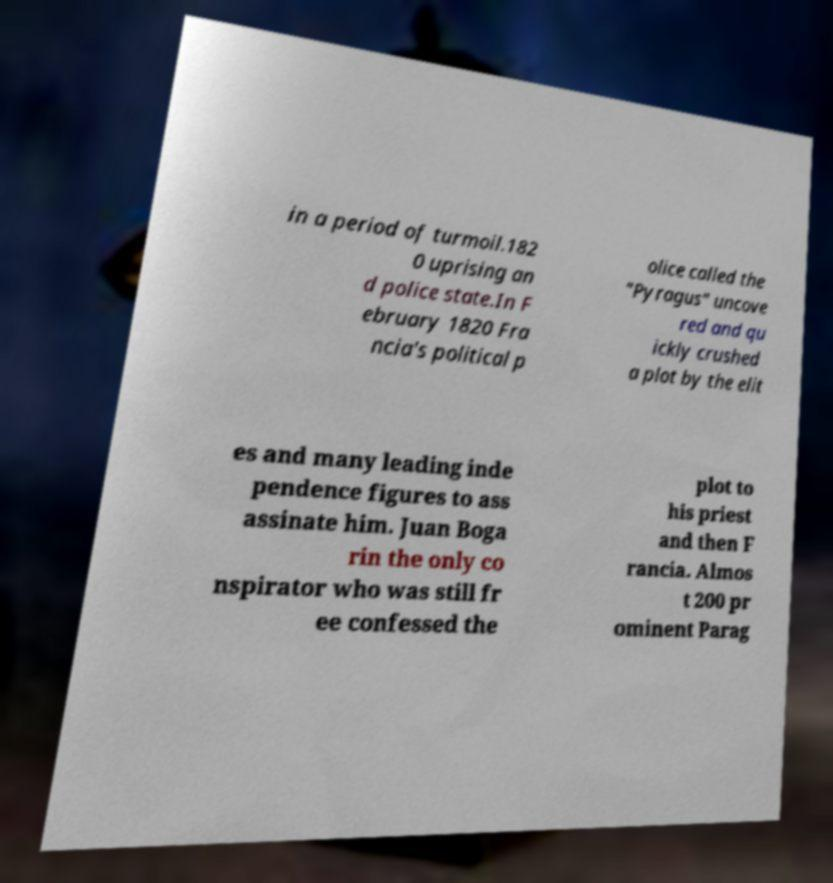Could you assist in decoding the text presented in this image and type it out clearly? in a period of turmoil.182 0 uprising an d police state.In F ebruary 1820 Fra ncia's political p olice called the "Pyragus" uncove red and qu ickly crushed a plot by the elit es and many leading inde pendence figures to ass assinate him. Juan Boga rin the only co nspirator who was still fr ee confessed the plot to his priest and then F rancia. Almos t 200 pr ominent Parag 